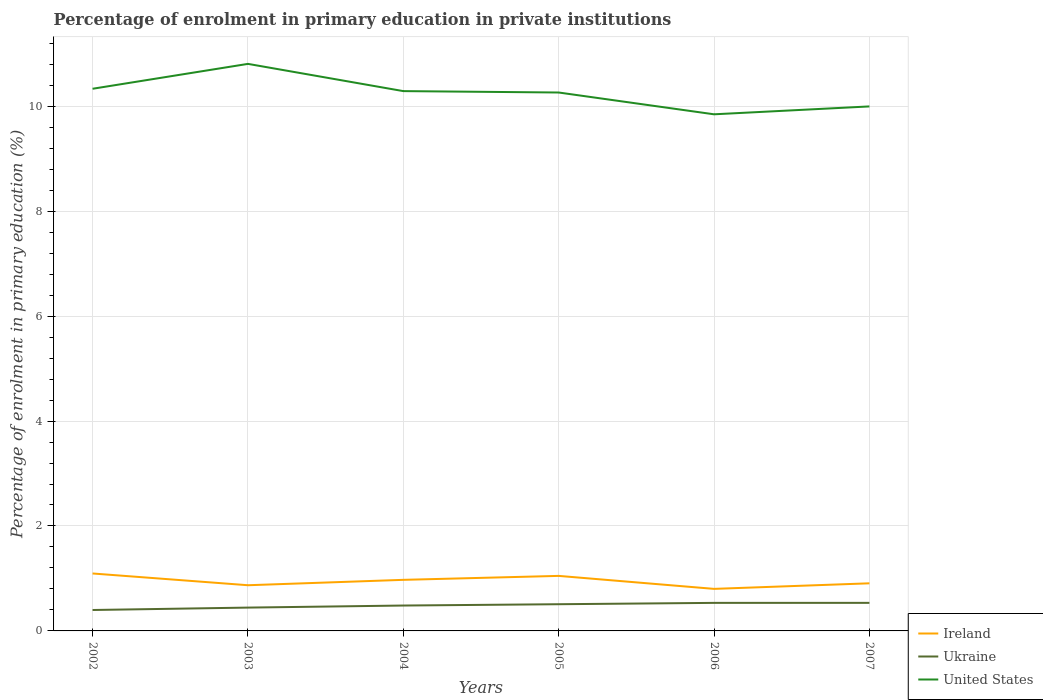Across all years, what is the maximum percentage of enrolment in primary education in Ukraine?
Provide a short and direct response. 0.4. In which year was the percentage of enrolment in primary education in United States maximum?
Your answer should be very brief. 2006. What is the total percentage of enrolment in primary education in United States in the graph?
Offer a terse response. -0.15. What is the difference between the highest and the second highest percentage of enrolment in primary education in Ukraine?
Your answer should be compact. 0.14. How many lines are there?
Ensure brevity in your answer.  3. How many years are there in the graph?
Provide a succinct answer. 6. What is the difference between two consecutive major ticks on the Y-axis?
Provide a short and direct response. 2. Are the values on the major ticks of Y-axis written in scientific E-notation?
Your answer should be very brief. No. Where does the legend appear in the graph?
Your answer should be compact. Bottom right. How are the legend labels stacked?
Make the answer very short. Vertical. What is the title of the graph?
Provide a succinct answer. Percentage of enrolment in primary education in private institutions. Does "Faeroe Islands" appear as one of the legend labels in the graph?
Offer a very short reply. No. What is the label or title of the X-axis?
Provide a succinct answer. Years. What is the label or title of the Y-axis?
Keep it short and to the point. Percentage of enrolment in primary education (%). What is the Percentage of enrolment in primary education (%) in Ireland in 2002?
Your answer should be compact. 1.09. What is the Percentage of enrolment in primary education (%) in Ukraine in 2002?
Give a very brief answer. 0.4. What is the Percentage of enrolment in primary education (%) of United States in 2002?
Make the answer very short. 10.33. What is the Percentage of enrolment in primary education (%) of Ireland in 2003?
Your response must be concise. 0.87. What is the Percentage of enrolment in primary education (%) of Ukraine in 2003?
Ensure brevity in your answer.  0.44. What is the Percentage of enrolment in primary education (%) in United States in 2003?
Make the answer very short. 10.81. What is the Percentage of enrolment in primary education (%) of Ireland in 2004?
Keep it short and to the point. 0.97. What is the Percentage of enrolment in primary education (%) in Ukraine in 2004?
Offer a terse response. 0.48. What is the Percentage of enrolment in primary education (%) in United States in 2004?
Make the answer very short. 10.29. What is the Percentage of enrolment in primary education (%) of Ireland in 2005?
Provide a succinct answer. 1.05. What is the Percentage of enrolment in primary education (%) in Ukraine in 2005?
Ensure brevity in your answer.  0.51. What is the Percentage of enrolment in primary education (%) of United States in 2005?
Provide a succinct answer. 10.26. What is the Percentage of enrolment in primary education (%) in Ireland in 2006?
Offer a very short reply. 0.8. What is the Percentage of enrolment in primary education (%) of Ukraine in 2006?
Give a very brief answer. 0.53. What is the Percentage of enrolment in primary education (%) of United States in 2006?
Your answer should be compact. 9.85. What is the Percentage of enrolment in primary education (%) in Ireland in 2007?
Offer a terse response. 0.91. What is the Percentage of enrolment in primary education (%) of Ukraine in 2007?
Your answer should be very brief. 0.53. What is the Percentage of enrolment in primary education (%) in United States in 2007?
Keep it short and to the point. 10. Across all years, what is the maximum Percentage of enrolment in primary education (%) in Ireland?
Offer a very short reply. 1.09. Across all years, what is the maximum Percentage of enrolment in primary education (%) in Ukraine?
Your answer should be compact. 0.53. Across all years, what is the maximum Percentage of enrolment in primary education (%) of United States?
Offer a terse response. 10.81. Across all years, what is the minimum Percentage of enrolment in primary education (%) in Ireland?
Your answer should be very brief. 0.8. Across all years, what is the minimum Percentage of enrolment in primary education (%) in Ukraine?
Make the answer very short. 0.4. Across all years, what is the minimum Percentage of enrolment in primary education (%) of United States?
Make the answer very short. 9.85. What is the total Percentage of enrolment in primary education (%) of Ireland in the graph?
Your response must be concise. 5.7. What is the total Percentage of enrolment in primary education (%) in Ukraine in the graph?
Your response must be concise. 2.91. What is the total Percentage of enrolment in primary education (%) of United States in the graph?
Keep it short and to the point. 61.53. What is the difference between the Percentage of enrolment in primary education (%) of Ireland in 2002 and that in 2003?
Keep it short and to the point. 0.22. What is the difference between the Percentage of enrolment in primary education (%) in Ukraine in 2002 and that in 2003?
Offer a terse response. -0.05. What is the difference between the Percentage of enrolment in primary education (%) in United States in 2002 and that in 2003?
Ensure brevity in your answer.  -0.47. What is the difference between the Percentage of enrolment in primary education (%) of Ireland in 2002 and that in 2004?
Give a very brief answer. 0.12. What is the difference between the Percentage of enrolment in primary education (%) in Ukraine in 2002 and that in 2004?
Offer a very short reply. -0.09. What is the difference between the Percentage of enrolment in primary education (%) of United States in 2002 and that in 2004?
Your answer should be very brief. 0.04. What is the difference between the Percentage of enrolment in primary education (%) in Ireland in 2002 and that in 2005?
Provide a succinct answer. 0.05. What is the difference between the Percentage of enrolment in primary education (%) of Ukraine in 2002 and that in 2005?
Make the answer very short. -0.11. What is the difference between the Percentage of enrolment in primary education (%) of United States in 2002 and that in 2005?
Provide a short and direct response. 0.07. What is the difference between the Percentage of enrolment in primary education (%) in Ireland in 2002 and that in 2006?
Keep it short and to the point. 0.29. What is the difference between the Percentage of enrolment in primary education (%) of Ukraine in 2002 and that in 2006?
Your answer should be compact. -0.14. What is the difference between the Percentage of enrolment in primary education (%) in United States in 2002 and that in 2006?
Ensure brevity in your answer.  0.49. What is the difference between the Percentage of enrolment in primary education (%) in Ireland in 2002 and that in 2007?
Your answer should be very brief. 0.19. What is the difference between the Percentage of enrolment in primary education (%) of Ukraine in 2002 and that in 2007?
Give a very brief answer. -0.14. What is the difference between the Percentage of enrolment in primary education (%) of United States in 2002 and that in 2007?
Offer a terse response. 0.34. What is the difference between the Percentage of enrolment in primary education (%) in Ireland in 2003 and that in 2004?
Keep it short and to the point. -0.1. What is the difference between the Percentage of enrolment in primary education (%) of Ukraine in 2003 and that in 2004?
Keep it short and to the point. -0.04. What is the difference between the Percentage of enrolment in primary education (%) in United States in 2003 and that in 2004?
Provide a succinct answer. 0.52. What is the difference between the Percentage of enrolment in primary education (%) of Ireland in 2003 and that in 2005?
Provide a short and direct response. -0.18. What is the difference between the Percentage of enrolment in primary education (%) in Ukraine in 2003 and that in 2005?
Your response must be concise. -0.06. What is the difference between the Percentage of enrolment in primary education (%) of United States in 2003 and that in 2005?
Your answer should be compact. 0.55. What is the difference between the Percentage of enrolment in primary education (%) of Ireland in 2003 and that in 2006?
Provide a short and direct response. 0.07. What is the difference between the Percentage of enrolment in primary education (%) of Ukraine in 2003 and that in 2006?
Offer a very short reply. -0.09. What is the difference between the Percentage of enrolment in primary education (%) of United States in 2003 and that in 2006?
Provide a succinct answer. 0.96. What is the difference between the Percentage of enrolment in primary education (%) of Ireland in 2003 and that in 2007?
Offer a terse response. -0.04. What is the difference between the Percentage of enrolment in primary education (%) of Ukraine in 2003 and that in 2007?
Make the answer very short. -0.09. What is the difference between the Percentage of enrolment in primary education (%) of United States in 2003 and that in 2007?
Your answer should be very brief. 0.81. What is the difference between the Percentage of enrolment in primary education (%) in Ireland in 2004 and that in 2005?
Give a very brief answer. -0.08. What is the difference between the Percentage of enrolment in primary education (%) in Ukraine in 2004 and that in 2005?
Your response must be concise. -0.03. What is the difference between the Percentage of enrolment in primary education (%) in United States in 2004 and that in 2005?
Your answer should be very brief. 0.03. What is the difference between the Percentage of enrolment in primary education (%) of Ireland in 2004 and that in 2006?
Provide a succinct answer. 0.17. What is the difference between the Percentage of enrolment in primary education (%) of Ukraine in 2004 and that in 2006?
Make the answer very short. -0.05. What is the difference between the Percentage of enrolment in primary education (%) in United States in 2004 and that in 2006?
Provide a succinct answer. 0.44. What is the difference between the Percentage of enrolment in primary education (%) of Ireland in 2004 and that in 2007?
Keep it short and to the point. 0.07. What is the difference between the Percentage of enrolment in primary education (%) in Ukraine in 2004 and that in 2007?
Offer a very short reply. -0.05. What is the difference between the Percentage of enrolment in primary education (%) of United States in 2004 and that in 2007?
Your answer should be compact. 0.29. What is the difference between the Percentage of enrolment in primary education (%) of Ireland in 2005 and that in 2006?
Your answer should be very brief. 0.25. What is the difference between the Percentage of enrolment in primary education (%) in Ukraine in 2005 and that in 2006?
Your answer should be compact. -0.03. What is the difference between the Percentage of enrolment in primary education (%) of United States in 2005 and that in 2006?
Your answer should be very brief. 0.42. What is the difference between the Percentage of enrolment in primary education (%) of Ireland in 2005 and that in 2007?
Your answer should be compact. 0.14. What is the difference between the Percentage of enrolment in primary education (%) in Ukraine in 2005 and that in 2007?
Ensure brevity in your answer.  -0.03. What is the difference between the Percentage of enrolment in primary education (%) of United States in 2005 and that in 2007?
Offer a terse response. 0.27. What is the difference between the Percentage of enrolment in primary education (%) of Ireland in 2006 and that in 2007?
Keep it short and to the point. -0.11. What is the difference between the Percentage of enrolment in primary education (%) in Ukraine in 2006 and that in 2007?
Offer a terse response. -0. What is the difference between the Percentage of enrolment in primary education (%) of United States in 2006 and that in 2007?
Your response must be concise. -0.15. What is the difference between the Percentage of enrolment in primary education (%) in Ireland in 2002 and the Percentage of enrolment in primary education (%) in Ukraine in 2003?
Offer a terse response. 0.65. What is the difference between the Percentage of enrolment in primary education (%) in Ireland in 2002 and the Percentage of enrolment in primary education (%) in United States in 2003?
Your answer should be very brief. -9.71. What is the difference between the Percentage of enrolment in primary education (%) in Ukraine in 2002 and the Percentage of enrolment in primary education (%) in United States in 2003?
Your answer should be compact. -10.41. What is the difference between the Percentage of enrolment in primary education (%) in Ireland in 2002 and the Percentage of enrolment in primary education (%) in Ukraine in 2004?
Your response must be concise. 0.61. What is the difference between the Percentage of enrolment in primary education (%) in Ireland in 2002 and the Percentage of enrolment in primary education (%) in United States in 2004?
Provide a short and direct response. -9.19. What is the difference between the Percentage of enrolment in primary education (%) in Ukraine in 2002 and the Percentage of enrolment in primary education (%) in United States in 2004?
Keep it short and to the point. -9.89. What is the difference between the Percentage of enrolment in primary education (%) of Ireland in 2002 and the Percentage of enrolment in primary education (%) of Ukraine in 2005?
Your response must be concise. 0.59. What is the difference between the Percentage of enrolment in primary education (%) of Ireland in 2002 and the Percentage of enrolment in primary education (%) of United States in 2005?
Offer a terse response. -9.17. What is the difference between the Percentage of enrolment in primary education (%) of Ukraine in 2002 and the Percentage of enrolment in primary education (%) of United States in 2005?
Provide a short and direct response. -9.86. What is the difference between the Percentage of enrolment in primary education (%) in Ireland in 2002 and the Percentage of enrolment in primary education (%) in Ukraine in 2006?
Your response must be concise. 0.56. What is the difference between the Percentage of enrolment in primary education (%) in Ireland in 2002 and the Percentage of enrolment in primary education (%) in United States in 2006?
Your answer should be compact. -8.75. What is the difference between the Percentage of enrolment in primary education (%) of Ukraine in 2002 and the Percentage of enrolment in primary education (%) of United States in 2006?
Keep it short and to the point. -9.45. What is the difference between the Percentage of enrolment in primary education (%) in Ireland in 2002 and the Percentage of enrolment in primary education (%) in Ukraine in 2007?
Offer a terse response. 0.56. What is the difference between the Percentage of enrolment in primary education (%) of Ireland in 2002 and the Percentage of enrolment in primary education (%) of United States in 2007?
Give a very brief answer. -8.9. What is the difference between the Percentage of enrolment in primary education (%) in Ukraine in 2002 and the Percentage of enrolment in primary education (%) in United States in 2007?
Provide a succinct answer. -9.6. What is the difference between the Percentage of enrolment in primary education (%) of Ireland in 2003 and the Percentage of enrolment in primary education (%) of Ukraine in 2004?
Ensure brevity in your answer.  0.39. What is the difference between the Percentage of enrolment in primary education (%) of Ireland in 2003 and the Percentage of enrolment in primary education (%) of United States in 2004?
Make the answer very short. -9.42. What is the difference between the Percentage of enrolment in primary education (%) of Ukraine in 2003 and the Percentage of enrolment in primary education (%) of United States in 2004?
Ensure brevity in your answer.  -9.84. What is the difference between the Percentage of enrolment in primary education (%) of Ireland in 2003 and the Percentage of enrolment in primary education (%) of Ukraine in 2005?
Ensure brevity in your answer.  0.36. What is the difference between the Percentage of enrolment in primary education (%) of Ireland in 2003 and the Percentage of enrolment in primary education (%) of United States in 2005?
Offer a very short reply. -9.39. What is the difference between the Percentage of enrolment in primary education (%) in Ukraine in 2003 and the Percentage of enrolment in primary education (%) in United States in 2005?
Your answer should be very brief. -9.82. What is the difference between the Percentage of enrolment in primary education (%) of Ireland in 2003 and the Percentage of enrolment in primary education (%) of Ukraine in 2006?
Your answer should be very brief. 0.34. What is the difference between the Percentage of enrolment in primary education (%) in Ireland in 2003 and the Percentage of enrolment in primary education (%) in United States in 2006?
Provide a short and direct response. -8.98. What is the difference between the Percentage of enrolment in primary education (%) in Ukraine in 2003 and the Percentage of enrolment in primary education (%) in United States in 2006?
Provide a short and direct response. -9.4. What is the difference between the Percentage of enrolment in primary education (%) in Ireland in 2003 and the Percentage of enrolment in primary education (%) in Ukraine in 2007?
Provide a succinct answer. 0.34. What is the difference between the Percentage of enrolment in primary education (%) of Ireland in 2003 and the Percentage of enrolment in primary education (%) of United States in 2007?
Your answer should be compact. -9.13. What is the difference between the Percentage of enrolment in primary education (%) of Ukraine in 2003 and the Percentage of enrolment in primary education (%) of United States in 2007?
Make the answer very short. -9.55. What is the difference between the Percentage of enrolment in primary education (%) of Ireland in 2004 and the Percentage of enrolment in primary education (%) of Ukraine in 2005?
Your response must be concise. 0.46. What is the difference between the Percentage of enrolment in primary education (%) in Ireland in 2004 and the Percentage of enrolment in primary education (%) in United States in 2005?
Provide a succinct answer. -9.29. What is the difference between the Percentage of enrolment in primary education (%) of Ukraine in 2004 and the Percentage of enrolment in primary education (%) of United States in 2005?
Make the answer very short. -9.78. What is the difference between the Percentage of enrolment in primary education (%) of Ireland in 2004 and the Percentage of enrolment in primary education (%) of Ukraine in 2006?
Offer a terse response. 0.44. What is the difference between the Percentage of enrolment in primary education (%) of Ireland in 2004 and the Percentage of enrolment in primary education (%) of United States in 2006?
Provide a short and direct response. -8.87. What is the difference between the Percentage of enrolment in primary education (%) in Ukraine in 2004 and the Percentage of enrolment in primary education (%) in United States in 2006?
Your response must be concise. -9.36. What is the difference between the Percentage of enrolment in primary education (%) of Ireland in 2004 and the Percentage of enrolment in primary education (%) of Ukraine in 2007?
Make the answer very short. 0.44. What is the difference between the Percentage of enrolment in primary education (%) of Ireland in 2004 and the Percentage of enrolment in primary education (%) of United States in 2007?
Provide a succinct answer. -9.02. What is the difference between the Percentage of enrolment in primary education (%) in Ukraine in 2004 and the Percentage of enrolment in primary education (%) in United States in 2007?
Provide a succinct answer. -9.51. What is the difference between the Percentage of enrolment in primary education (%) of Ireland in 2005 and the Percentage of enrolment in primary education (%) of Ukraine in 2006?
Offer a terse response. 0.51. What is the difference between the Percentage of enrolment in primary education (%) in Ireland in 2005 and the Percentage of enrolment in primary education (%) in United States in 2006?
Make the answer very short. -8.8. What is the difference between the Percentage of enrolment in primary education (%) of Ukraine in 2005 and the Percentage of enrolment in primary education (%) of United States in 2006?
Give a very brief answer. -9.34. What is the difference between the Percentage of enrolment in primary education (%) in Ireland in 2005 and the Percentage of enrolment in primary education (%) in Ukraine in 2007?
Your response must be concise. 0.51. What is the difference between the Percentage of enrolment in primary education (%) of Ireland in 2005 and the Percentage of enrolment in primary education (%) of United States in 2007?
Your answer should be compact. -8.95. What is the difference between the Percentage of enrolment in primary education (%) in Ukraine in 2005 and the Percentage of enrolment in primary education (%) in United States in 2007?
Give a very brief answer. -9.49. What is the difference between the Percentage of enrolment in primary education (%) in Ireland in 2006 and the Percentage of enrolment in primary education (%) in Ukraine in 2007?
Make the answer very short. 0.27. What is the difference between the Percentage of enrolment in primary education (%) of Ireland in 2006 and the Percentage of enrolment in primary education (%) of United States in 2007?
Your response must be concise. -9.19. What is the difference between the Percentage of enrolment in primary education (%) of Ukraine in 2006 and the Percentage of enrolment in primary education (%) of United States in 2007?
Your answer should be compact. -9.46. What is the average Percentage of enrolment in primary education (%) in Ireland per year?
Make the answer very short. 0.95. What is the average Percentage of enrolment in primary education (%) of Ukraine per year?
Provide a succinct answer. 0.48. What is the average Percentage of enrolment in primary education (%) in United States per year?
Keep it short and to the point. 10.26. In the year 2002, what is the difference between the Percentage of enrolment in primary education (%) in Ireland and Percentage of enrolment in primary education (%) in Ukraine?
Ensure brevity in your answer.  0.7. In the year 2002, what is the difference between the Percentage of enrolment in primary education (%) of Ireland and Percentage of enrolment in primary education (%) of United States?
Ensure brevity in your answer.  -9.24. In the year 2002, what is the difference between the Percentage of enrolment in primary education (%) of Ukraine and Percentage of enrolment in primary education (%) of United States?
Give a very brief answer. -9.93. In the year 2003, what is the difference between the Percentage of enrolment in primary education (%) in Ireland and Percentage of enrolment in primary education (%) in Ukraine?
Make the answer very short. 0.43. In the year 2003, what is the difference between the Percentage of enrolment in primary education (%) of Ireland and Percentage of enrolment in primary education (%) of United States?
Provide a short and direct response. -9.94. In the year 2003, what is the difference between the Percentage of enrolment in primary education (%) of Ukraine and Percentage of enrolment in primary education (%) of United States?
Offer a terse response. -10.36. In the year 2004, what is the difference between the Percentage of enrolment in primary education (%) in Ireland and Percentage of enrolment in primary education (%) in Ukraine?
Offer a terse response. 0.49. In the year 2004, what is the difference between the Percentage of enrolment in primary education (%) of Ireland and Percentage of enrolment in primary education (%) of United States?
Your response must be concise. -9.31. In the year 2004, what is the difference between the Percentage of enrolment in primary education (%) in Ukraine and Percentage of enrolment in primary education (%) in United States?
Give a very brief answer. -9.8. In the year 2005, what is the difference between the Percentage of enrolment in primary education (%) in Ireland and Percentage of enrolment in primary education (%) in Ukraine?
Your answer should be very brief. 0.54. In the year 2005, what is the difference between the Percentage of enrolment in primary education (%) of Ireland and Percentage of enrolment in primary education (%) of United States?
Your answer should be very brief. -9.21. In the year 2005, what is the difference between the Percentage of enrolment in primary education (%) of Ukraine and Percentage of enrolment in primary education (%) of United States?
Your answer should be very brief. -9.75. In the year 2006, what is the difference between the Percentage of enrolment in primary education (%) in Ireland and Percentage of enrolment in primary education (%) in Ukraine?
Offer a very short reply. 0.27. In the year 2006, what is the difference between the Percentage of enrolment in primary education (%) in Ireland and Percentage of enrolment in primary education (%) in United States?
Your answer should be very brief. -9.04. In the year 2006, what is the difference between the Percentage of enrolment in primary education (%) of Ukraine and Percentage of enrolment in primary education (%) of United States?
Make the answer very short. -9.31. In the year 2007, what is the difference between the Percentage of enrolment in primary education (%) of Ireland and Percentage of enrolment in primary education (%) of Ukraine?
Make the answer very short. 0.37. In the year 2007, what is the difference between the Percentage of enrolment in primary education (%) of Ireland and Percentage of enrolment in primary education (%) of United States?
Ensure brevity in your answer.  -9.09. In the year 2007, what is the difference between the Percentage of enrolment in primary education (%) of Ukraine and Percentage of enrolment in primary education (%) of United States?
Ensure brevity in your answer.  -9.46. What is the ratio of the Percentage of enrolment in primary education (%) in Ireland in 2002 to that in 2003?
Your response must be concise. 1.26. What is the ratio of the Percentage of enrolment in primary education (%) in Ukraine in 2002 to that in 2003?
Make the answer very short. 0.9. What is the ratio of the Percentage of enrolment in primary education (%) in United States in 2002 to that in 2003?
Make the answer very short. 0.96. What is the ratio of the Percentage of enrolment in primary education (%) in Ireland in 2002 to that in 2004?
Ensure brevity in your answer.  1.12. What is the ratio of the Percentage of enrolment in primary education (%) of Ukraine in 2002 to that in 2004?
Provide a short and direct response. 0.82. What is the ratio of the Percentage of enrolment in primary education (%) in United States in 2002 to that in 2004?
Your answer should be very brief. 1. What is the ratio of the Percentage of enrolment in primary education (%) of Ireland in 2002 to that in 2005?
Provide a short and direct response. 1.04. What is the ratio of the Percentage of enrolment in primary education (%) of Ukraine in 2002 to that in 2005?
Ensure brevity in your answer.  0.78. What is the ratio of the Percentage of enrolment in primary education (%) in Ireland in 2002 to that in 2006?
Offer a terse response. 1.37. What is the ratio of the Percentage of enrolment in primary education (%) in Ukraine in 2002 to that in 2006?
Offer a terse response. 0.75. What is the ratio of the Percentage of enrolment in primary education (%) in United States in 2002 to that in 2006?
Your response must be concise. 1.05. What is the ratio of the Percentage of enrolment in primary education (%) of Ireland in 2002 to that in 2007?
Provide a succinct answer. 1.21. What is the ratio of the Percentage of enrolment in primary education (%) of Ukraine in 2002 to that in 2007?
Give a very brief answer. 0.75. What is the ratio of the Percentage of enrolment in primary education (%) of United States in 2002 to that in 2007?
Provide a short and direct response. 1.03. What is the ratio of the Percentage of enrolment in primary education (%) of Ireland in 2003 to that in 2004?
Provide a short and direct response. 0.89. What is the ratio of the Percentage of enrolment in primary education (%) of Ukraine in 2003 to that in 2004?
Offer a terse response. 0.92. What is the ratio of the Percentage of enrolment in primary education (%) in United States in 2003 to that in 2004?
Provide a short and direct response. 1.05. What is the ratio of the Percentage of enrolment in primary education (%) of Ireland in 2003 to that in 2005?
Your answer should be compact. 0.83. What is the ratio of the Percentage of enrolment in primary education (%) of Ukraine in 2003 to that in 2005?
Offer a terse response. 0.87. What is the ratio of the Percentage of enrolment in primary education (%) in United States in 2003 to that in 2005?
Provide a short and direct response. 1.05. What is the ratio of the Percentage of enrolment in primary education (%) in Ireland in 2003 to that in 2006?
Provide a short and direct response. 1.09. What is the ratio of the Percentage of enrolment in primary education (%) of Ukraine in 2003 to that in 2006?
Offer a terse response. 0.83. What is the ratio of the Percentage of enrolment in primary education (%) in United States in 2003 to that in 2006?
Give a very brief answer. 1.1. What is the ratio of the Percentage of enrolment in primary education (%) in Ireland in 2003 to that in 2007?
Provide a short and direct response. 0.96. What is the ratio of the Percentage of enrolment in primary education (%) of Ukraine in 2003 to that in 2007?
Keep it short and to the point. 0.83. What is the ratio of the Percentage of enrolment in primary education (%) in United States in 2003 to that in 2007?
Offer a terse response. 1.08. What is the ratio of the Percentage of enrolment in primary education (%) in Ireland in 2004 to that in 2005?
Give a very brief answer. 0.93. What is the ratio of the Percentage of enrolment in primary education (%) in Ukraine in 2004 to that in 2005?
Offer a very short reply. 0.95. What is the ratio of the Percentage of enrolment in primary education (%) of Ireland in 2004 to that in 2006?
Provide a succinct answer. 1.21. What is the ratio of the Percentage of enrolment in primary education (%) in Ukraine in 2004 to that in 2006?
Provide a succinct answer. 0.91. What is the ratio of the Percentage of enrolment in primary education (%) in United States in 2004 to that in 2006?
Provide a short and direct response. 1.04. What is the ratio of the Percentage of enrolment in primary education (%) in Ireland in 2004 to that in 2007?
Offer a terse response. 1.07. What is the ratio of the Percentage of enrolment in primary education (%) in Ukraine in 2004 to that in 2007?
Keep it short and to the point. 0.9. What is the ratio of the Percentage of enrolment in primary education (%) of United States in 2004 to that in 2007?
Ensure brevity in your answer.  1.03. What is the ratio of the Percentage of enrolment in primary education (%) in Ireland in 2005 to that in 2006?
Make the answer very short. 1.31. What is the ratio of the Percentage of enrolment in primary education (%) of Ukraine in 2005 to that in 2006?
Your answer should be very brief. 0.95. What is the ratio of the Percentage of enrolment in primary education (%) of United States in 2005 to that in 2006?
Your answer should be compact. 1.04. What is the ratio of the Percentage of enrolment in primary education (%) in Ireland in 2005 to that in 2007?
Offer a terse response. 1.16. What is the ratio of the Percentage of enrolment in primary education (%) of Ukraine in 2005 to that in 2007?
Your answer should be very brief. 0.95. What is the ratio of the Percentage of enrolment in primary education (%) of United States in 2005 to that in 2007?
Give a very brief answer. 1.03. What is the ratio of the Percentage of enrolment in primary education (%) of Ireland in 2006 to that in 2007?
Ensure brevity in your answer.  0.88. What is the ratio of the Percentage of enrolment in primary education (%) in Ukraine in 2006 to that in 2007?
Make the answer very short. 1. What is the ratio of the Percentage of enrolment in primary education (%) in United States in 2006 to that in 2007?
Keep it short and to the point. 0.98. What is the difference between the highest and the second highest Percentage of enrolment in primary education (%) in Ireland?
Offer a very short reply. 0.05. What is the difference between the highest and the second highest Percentage of enrolment in primary education (%) in Ukraine?
Your answer should be very brief. 0. What is the difference between the highest and the second highest Percentage of enrolment in primary education (%) of United States?
Ensure brevity in your answer.  0.47. What is the difference between the highest and the lowest Percentage of enrolment in primary education (%) of Ireland?
Provide a short and direct response. 0.29. What is the difference between the highest and the lowest Percentage of enrolment in primary education (%) of Ukraine?
Make the answer very short. 0.14. What is the difference between the highest and the lowest Percentage of enrolment in primary education (%) in United States?
Keep it short and to the point. 0.96. 